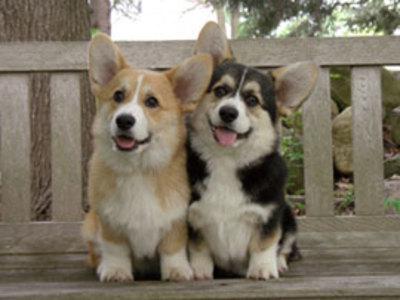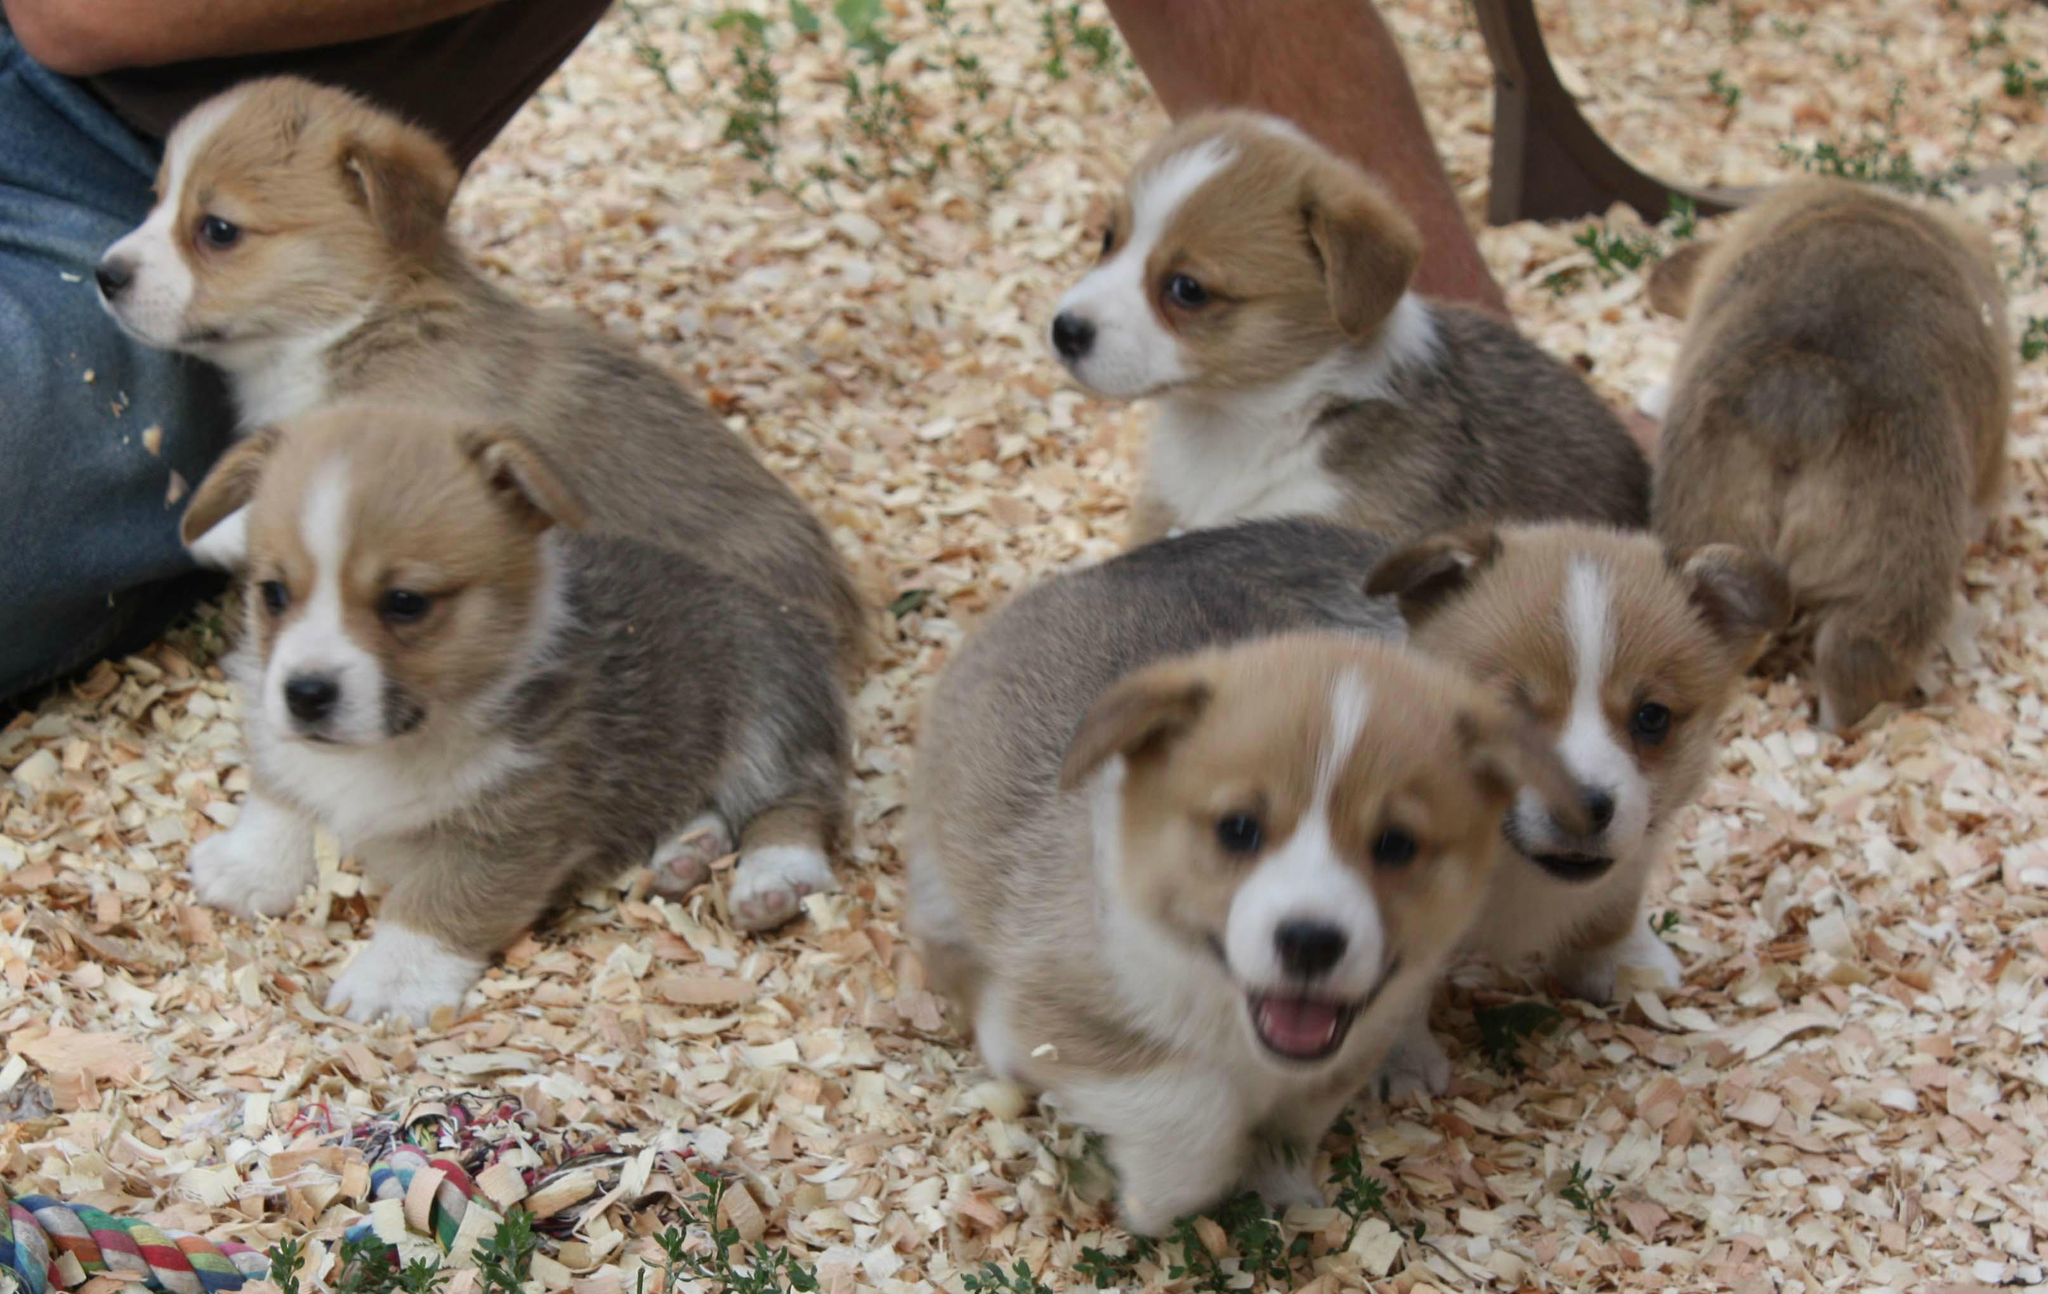The first image is the image on the left, the second image is the image on the right. Examine the images to the left and right. Is the description "There are at most four dogs." accurate? Answer yes or no. No. The first image is the image on the left, the second image is the image on the right. Considering the images on both sides, is "One imag shows a tri-color corgi dog posed side-by-side with an orange-and-white corgi dog, with their bodies turned forward." valid? Answer yes or no. Yes. 